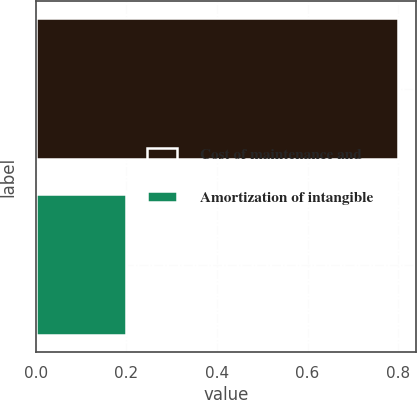<chart> <loc_0><loc_0><loc_500><loc_500><bar_chart><fcel>Cost of maintenance and<fcel>Amortization of intangible<nl><fcel>0.8<fcel>0.2<nl></chart> 